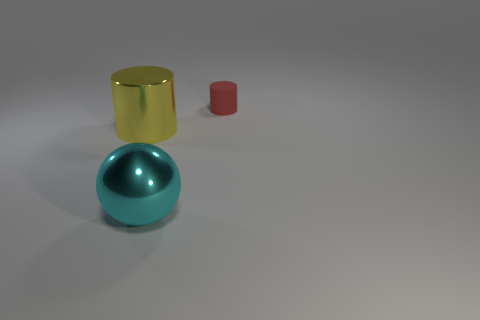The metal sphere is what color? The metal sphere exhibits a pleasing shade of cyan, characterized by a glossy finish that suggests a polished surface, reflective of its surroundings. 